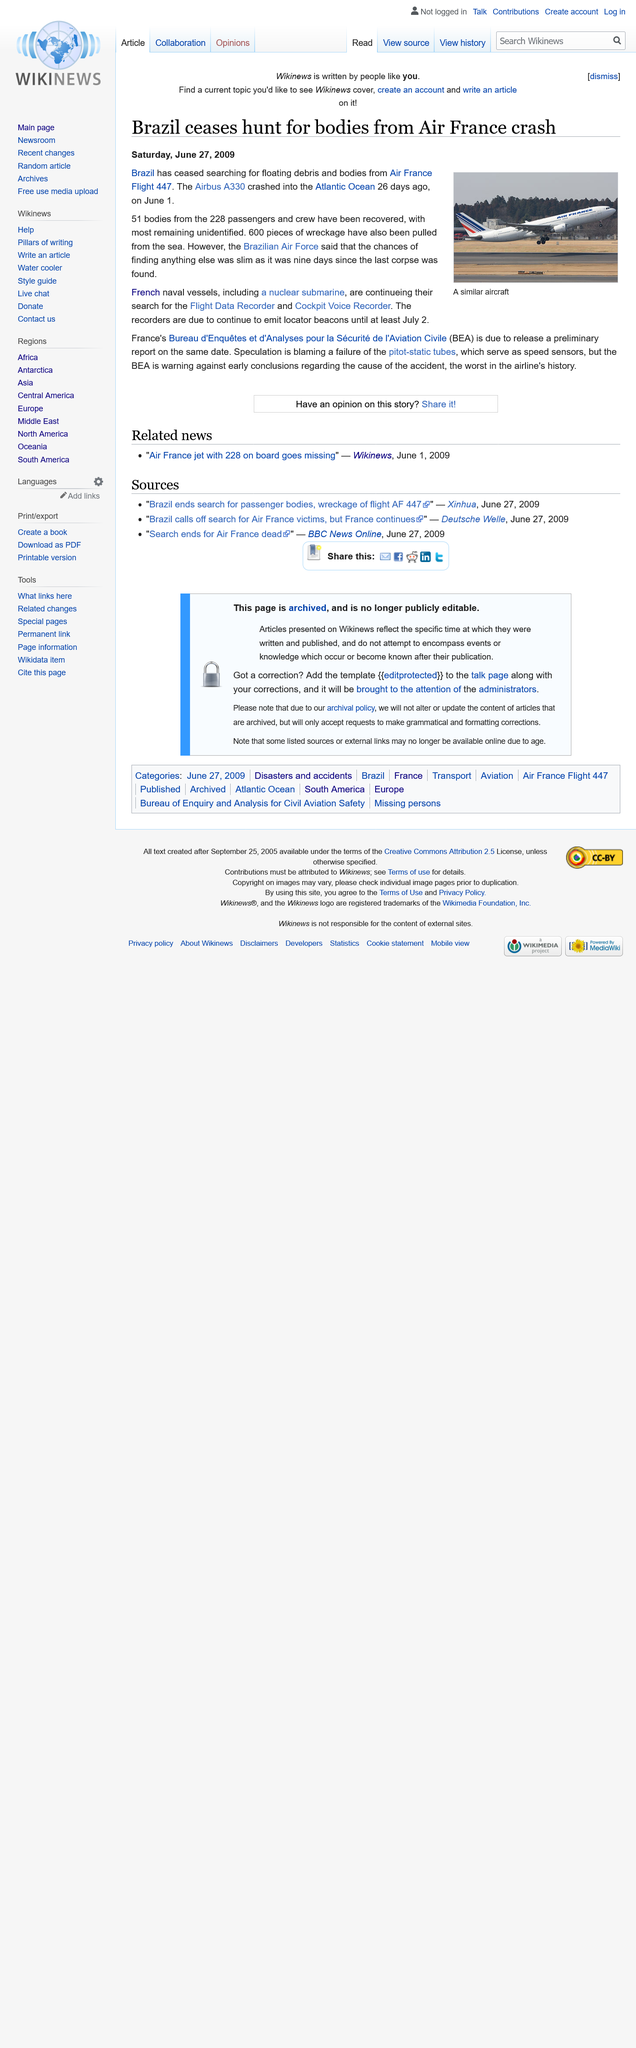Give some essential details in this illustration. The plane crashed into the Atlantic Ocean on June 1st, 2009. The recovery of 51 bodies from the wreckage of the 228 passengers and crew has been confirmed. On June 27th 2009, the article was published. 